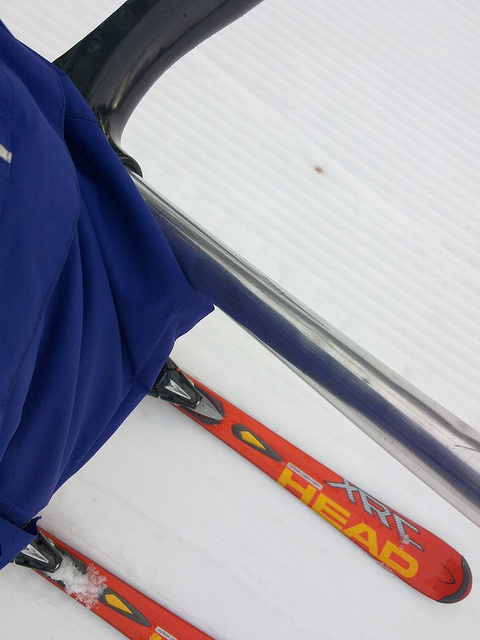Describe the objects in this image and their specific colors. I can see people in lightgray, navy, and darkgray tones and skis in lightgray, brown, red, darkgray, and orange tones in this image. 